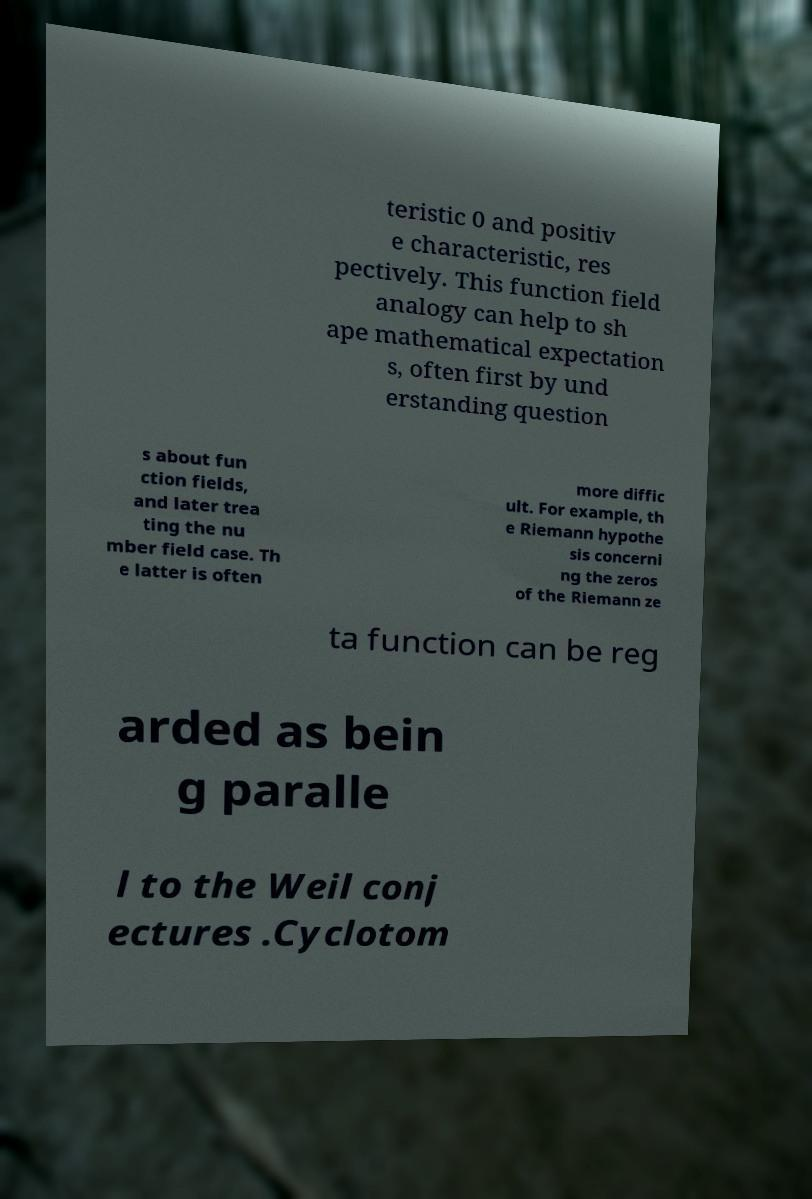Please identify and transcribe the text found in this image. teristic 0 and positiv e characteristic, res pectively. This function field analogy can help to sh ape mathematical expectation s, often first by und erstanding question s about fun ction fields, and later trea ting the nu mber field case. Th e latter is often more diffic ult. For example, th e Riemann hypothe sis concerni ng the zeros of the Riemann ze ta function can be reg arded as bein g paralle l to the Weil conj ectures .Cyclotom 